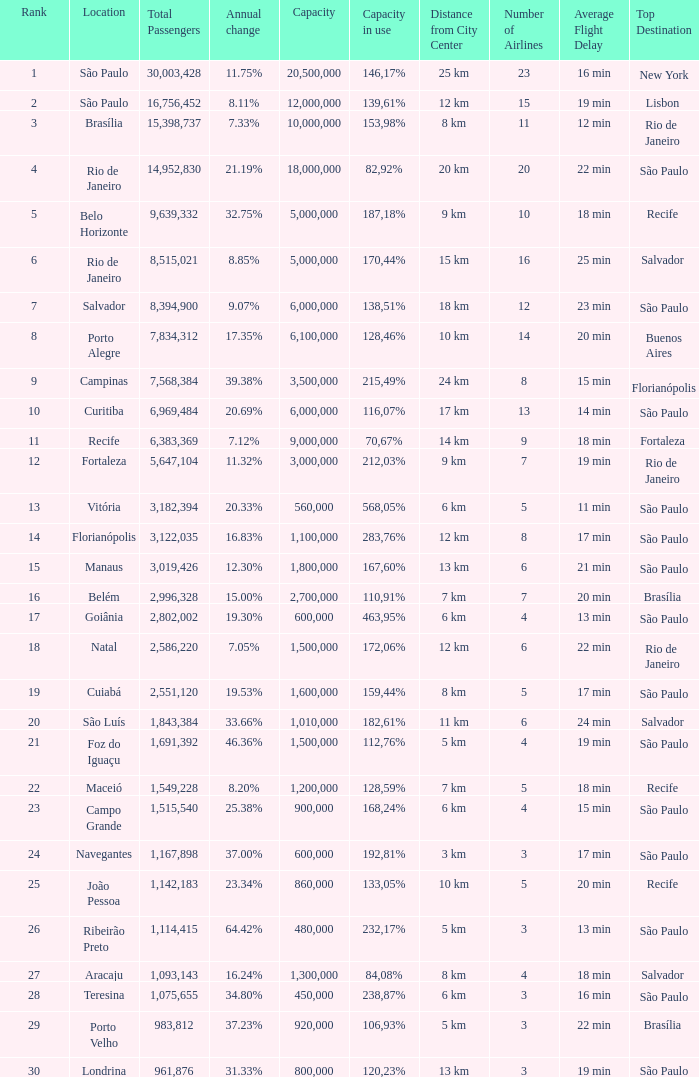What location has an in use capacity of 167,60%? 1800000.0. 